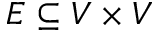<formula> <loc_0><loc_0><loc_500><loc_500>E \subseteq V \times V</formula> 